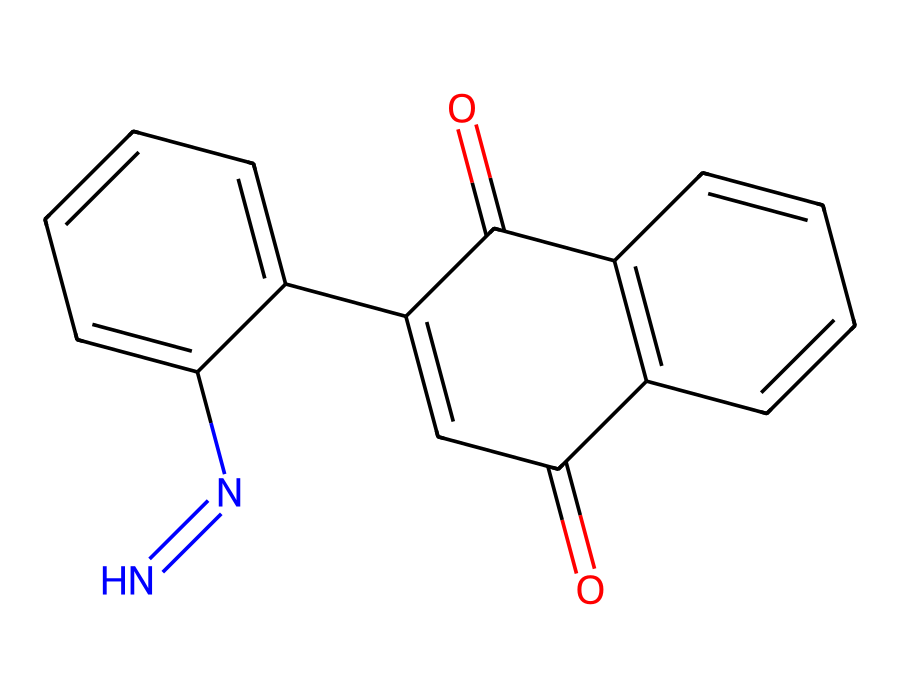What is the molecular formula of AZ 5214? Analyzing the structure represented by the SMILES indicates the inclusion of carbon (C), hydrogen (H), nitrogen (N), and oxygen (O) atoms. Counting the atoms in the structure reveals that there are 16 carbons, 12 hydrogens, 2 nitrogens, and 4 oxygens, leading to the molecular formula C16H12N2O4.
Answer: C16H12N2O4 How many rings are present in the structure of AZ 5214? By examining the SMILES representation, we can identify that there are two distinct ring systems as it contains two "C" counts with numbers indicating start and endpoints for cyclic formations. Thus, the structure consists of two rings.
Answer: 2 What functional groups can be identified in AZ 5214? The SMILES indicates the presence of carbonyl functional groups (C=O) and an azo bond (N=N). The carbonyl groups indicate the presence of ketones or aldehydes, and the -N=N- bond is characteristic of azo compounds.
Answer: carbonyl and azo What kind of reaction process is AZ 5214 primarily used for? AZ 5214 is specifically used in image reversal processes in photolithography, where exposure to light forms a defined pattern that can be developed later. This is essential in semiconductor fabrication.
Answer: image reversal What is the role of the nitrogen atoms in the AZ 5214 structure? The nitrogen atoms are part of the azo group, which contributes to the chemical properties of the photoresist, such as sensitivity to light exposure and the ability to create sharp images during the photolithography process.
Answer: sensitivity and imaging What is the implication of having double bonds within the structure of AZ 5214? The presence of double bonds (C=C) in the structure indicates unsaturation, which can significantly affect the reactivity of the chemical, enhancing its performance in photochemical processes by allowing for more complex interactions when exposed to light.
Answer: enhanced reactivity 